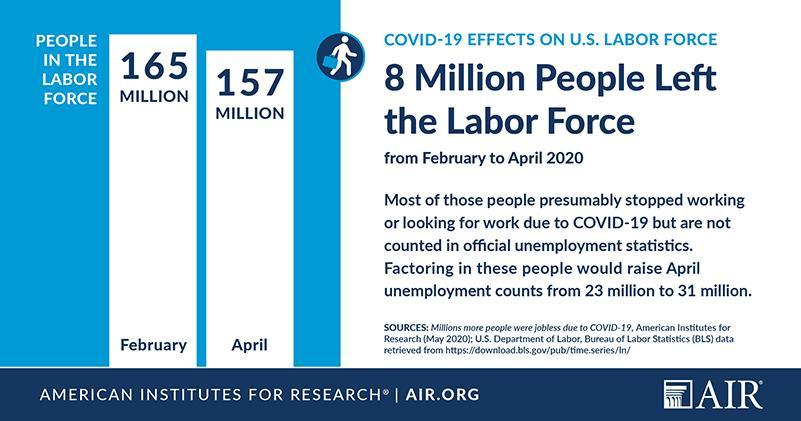How many people are working in the U.S. labor force in February 2020?
Answer the question with a short phrase. 165 MILLION How many people are working in the U.S. labor force in April 2020? 157 MILLION 